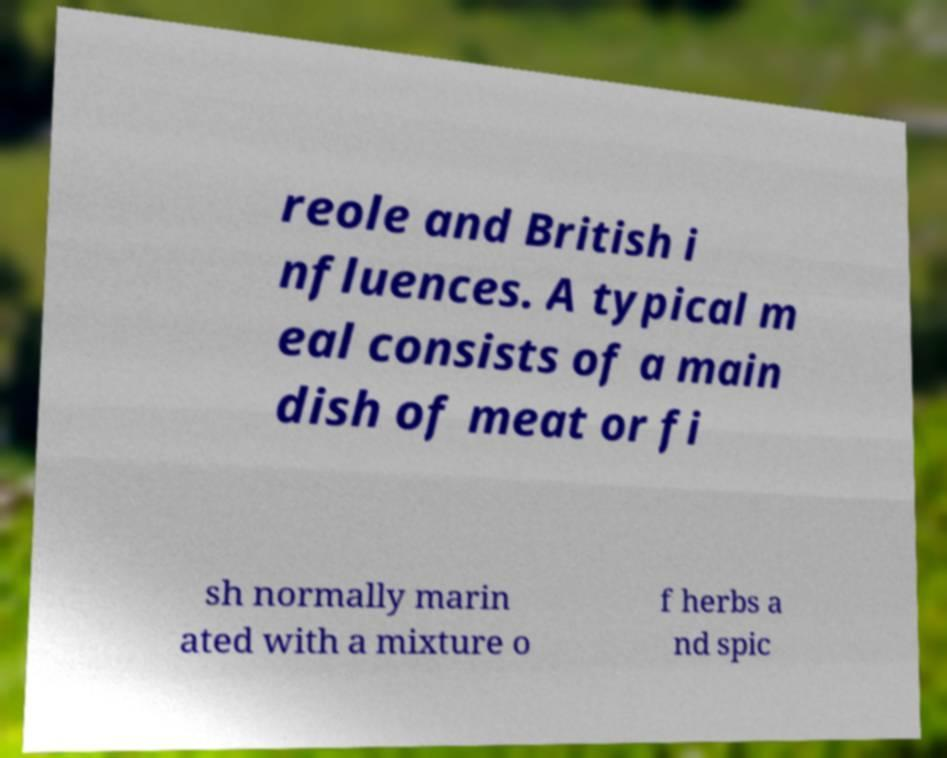What messages or text are displayed in this image? I need them in a readable, typed format. reole and British i nfluences. A typical m eal consists of a main dish of meat or fi sh normally marin ated with a mixture o f herbs a nd spic 